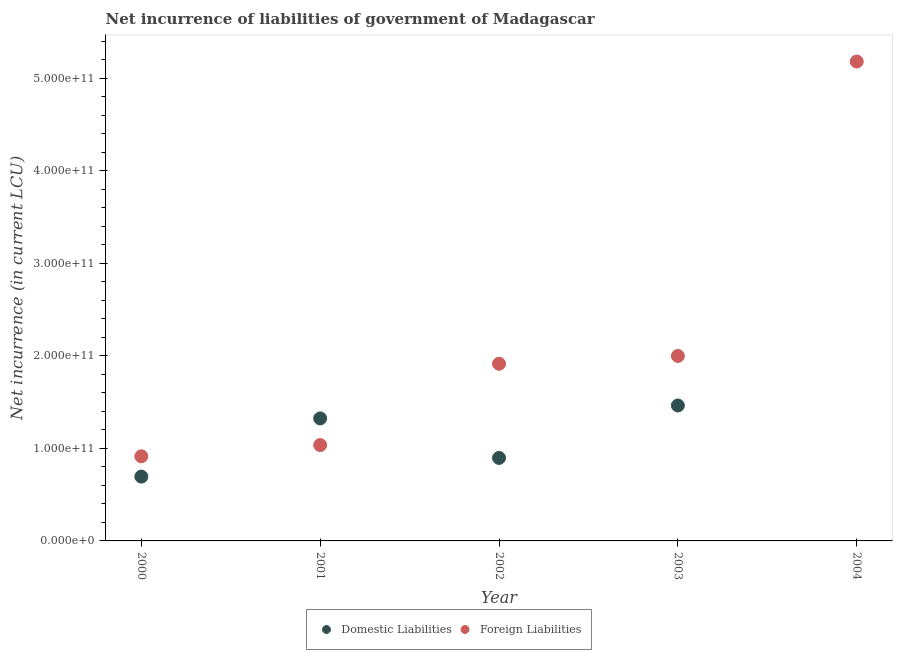Is the number of dotlines equal to the number of legend labels?
Offer a very short reply. No. What is the net incurrence of foreign liabilities in 2003?
Your answer should be compact. 2.00e+11. Across all years, what is the maximum net incurrence of domestic liabilities?
Provide a succinct answer. 1.46e+11. Across all years, what is the minimum net incurrence of domestic liabilities?
Keep it short and to the point. 0. What is the total net incurrence of domestic liabilities in the graph?
Provide a short and direct response. 4.38e+11. What is the difference between the net incurrence of foreign liabilities in 2001 and that in 2002?
Give a very brief answer. -8.79e+1. What is the difference between the net incurrence of domestic liabilities in 2000 and the net incurrence of foreign liabilities in 2004?
Provide a short and direct response. -4.49e+11. What is the average net incurrence of domestic liabilities per year?
Your answer should be very brief. 8.76e+1. In the year 2000, what is the difference between the net incurrence of domestic liabilities and net incurrence of foreign liabilities?
Keep it short and to the point. -2.20e+1. What is the ratio of the net incurrence of domestic liabilities in 2000 to that in 2002?
Ensure brevity in your answer.  0.77. Is the difference between the net incurrence of foreign liabilities in 2000 and 2001 greater than the difference between the net incurrence of domestic liabilities in 2000 and 2001?
Your response must be concise. Yes. What is the difference between the highest and the second highest net incurrence of domestic liabilities?
Offer a very short reply. 1.39e+1. What is the difference between the highest and the lowest net incurrence of domestic liabilities?
Your response must be concise. 1.46e+11. Is the net incurrence of domestic liabilities strictly less than the net incurrence of foreign liabilities over the years?
Offer a terse response. No. How many years are there in the graph?
Your answer should be compact. 5. What is the difference between two consecutive major ticks on the Y-axis?
Your response must be concise. 1.00e+11. What is the title of the graph?
Provide a short and direct response. Net incurrence of liabilities of government of Madagascar. Does "Diarrhea" appear as one of the legend labels in the graph?
Your answer should be compact. No. What is the label or title of the X-axis?
Provide a short and direct response. Year. What is the label or title of the Y-axis?
Provide a succinct answer. Net incurrence (in current LCU). What is the Net incurrence (in current LCU) of Domestic Liabilities in 2000?
Provide a short and direct response. 6.95e+1. What is the Net incurrence (in current LCU) of Foreign Liabilities in 2000?
Provide a short and direct response. 9.15e+1. What is the Net incurrence (in current LCU) in Domestic Liabilities in 2001?
Offer a terse response. 1.32e+11. What is the Net incurrence (in current LCU) in Foreign Liabilities in 2001?
Make the answer very short. 1.04e+11. What is the Net incurrence (in current LCU) of Domestic Liabilities in 2002?
Keep it short and to the point. 8.97e+1. What is the Net incurrence (in current LCU) of Foreign Liabilities in 2002?
Keep it short and to the point. 1.92e+11. What is the Net incurrence (in current LCU) of Domestic Liabilities in 2003?
Offer a terse response. 1.46e+11. What is the Net incurrence (in current LCU) in Foreign Liabilities in 2003?
Keep it short and to the point. 2.00e+11. What is the Net incurrence (in current LCU) of Domestic Liabilities in 2004?
Ensure brevity in your answer.  0. What is the Net incurrence (in current LCU) of Foreign Liabilities in 2004?
Your response must be concise. 5.18e+11. Across all years, what is the maximum Net incurrence (in current LCU) in Domestic Liabilities?
Your answer should be very brief. 1.46e+11. Across all years, what is the maximum Net incurrence (in current LCU) of Foreign Liabilities?
Provide a succinct answer. 5.18e+11. Across all years, what is the minimum Net incurrence (in current LCU) of Domestic Liabilities?
Make the answer very short. 0. Across all years, what is the minimum Net incurrence (in current LCU) in Foreign Liabilities?
Give a very brief answer. 9.15e+1. What is the total Net incurrence (in current LCU) of Domestic Liabilities in the graph?
Offer a terse response. 4.38e+11. What is the total Net incurrence (in current LCU) in Foreign Liabilities in the graph?
Your answer should be very brief. 1.10e+12. What is the difference between the Net incurrence (in current LCU) in Domestic Liabilities in 2000 and that in 2001?
Offer a terse response. -6.29e+1. What is the difference between the Net incurrence (in current LCU) of Foreign Liabilities in 2000 and that in 2001?
Provide a short and direct response. -1.21e+1. What is the difference between the Net incurrence (in current LCU) in Domestic Liabilities in 2000 and that in 2002?
Your answer should be compact. -2.02e+1. What is the difference between the Net incurrence (in current LCU) in Foreign Liabilities in 2000 and that in 2002?
Offer a terse response. -1.00e+11. What is the difference between the Net incurrence (in current LCU) of Domestic Liabilities in 2000 and that in 2003?
Provide a succinct answer. -7.69e+1. What is the difference between the Net incurrence (in current LCU) in Foreign Liabilities in 2000 and that in 2003?
Give a very brief answer. -1.08e+11. What is the difference between the Net incurrence (in current LCU) in Foreign Liabilities in 2000 and that in 2004?
Provide a short and direct response. -4.27e+11. What is the difference between the Net incurrence (in current LCU) of Domestic Liabilities in 2001 and that in 2002?
Ensure brevity in your answer.  4.27e+1. What is the difference between the Net incurrence (in current LCU) in Foreign Liabilities in 2001 and that in 2002?
Ensure brevity in your answer.  -8.79e+1. What is the difference between the Net incurrence (in current LCU) of Domestic Liabilities in 2001 and that in 2003?
Give a very brief answer. -1.39e+1. What is the difference between the Net incurrence (in current LCU) of Foreign Liabilities in 2001 and that in 2003?
Offer a terse response. -9.64e+1. What is the difference between the Net incurrence (in current LCU) in Foreign Liabilities in 2001 and that in 2004?
Offer a very short reply. -4.15e+11. What is the difference between the Net incurrence (in current LCU) of Domestic Liabilities in 2002 and that in 2003?
Your response must be concise. -5.67e+1. What is the difference between the Net incurrence (in current LCU) of Foreign Liabilities in 2002 and that in 2003?
Your response must be concise. -8.48e+09. What is the difference between the Net incurrence (in current LCU) in Foreign Liabilities in 2002 and that in 2004?
Keep it short and to the point. -3.27e+11. What is the difference between the Net incurrence (in current LCU) in Foreign Liabilities in 2003 and that in 2004?
Ensure brevity in your answer.  -3.18e+11. What is the difference between the Net incurrence (in current LCU) in Domestic Liabilities in 2000 and the Net incurrence (in current LCU) in Foreign Liabilities in 2001?
Your answer should be very brief. -3.41e+1. What is the difference between the Net incurrence (in current LCU) in Domestic Liabilities in 2000 and the Net incurrence (in current LCU) in Foreign Liabilities in 2002?
Your answer should be very brief. -1.22e+11. What is the difference between the Net incurrence (in current LCU) in Domestic Liabilities in 2000 and the Net incurrence (in current LCU) in Foreign Liabilities in 2003?
Offer a very short reply. -1.30e+11. What is the difference between the Net incurrence (in current LCU) in Domestic Liabilities in 2000 and the Net incurrence (in current LCU) in Foreign Liabilities in 2004?
Offer a terse response. -4.49e+11. What is the difference between the Net incurrence (in current LCU) in Domestic Liabilities in 2001 and the Net incurrence (in current LCU) in Foreign Liabilities in 2002?
Ensure brevity in your answer.  -5.91e+1. What is the difference between the Net incurrence (in current LCU) in Domestic Liabilities in 2001 and the Net incurrence (in current LCU) in Foreign Liabilities in 2003?
Provide a succinct answer. -6.75e+1. What is the difference between the Net incurrence (in current LCU) of Domestic Liabilities in 2001 and the Net incurrence (in current LCU) of Foreign Liabilities in 2004?
Offer a very short reply. -3.86e+11. What is the difference between the Net incurrence (in current LCU) of Domestic Liabilities in 2002 and the Net incurrence (in current LCU) of Foreign Liabilities in 2003?
Your response must be concise. -1.10e+11. What is the difference between the Net incurrence (in current LCU) of Domestic Liabilities in 2002 and the Net incurrence (in current LCU) of Foreign Liabilities in 2004?
Provide a succinct answer. -4.28e+11. What is the difference between the Net incurrence (in current LCU) of Domestic Liabilities in 2003 and the Net incurrence (in current LCU) of Foreign Liabilities in 2004?
Provide a succinct answer. -3.72e+11. What is the average Net incurrence (in current LCU) of Domestic Liabilities per year?
Make the answer very short. 8.76e+1. What is the average Net incurrence (in current LCU) of Foreign Liabilities per year?
Your answer should be very brief. 2.21e+11. In the year 2000, what is the difference between the Net incurrence (in current LCU) of Domestic Liabilities and Net incurrence (in current LCU) of Foreign Liabilities?
Offer a very short reply. -2.20e+1. In the year 2001, what is the difference between the Net incurrence (in current LCU) in Domestic Liabilities and Net incurrence (in current LCU) in Foreign Liabilities?
Give a very brief answer. 2.88e+1. In the year 2002, what is the difference between the Net incurrence (in current LCU) in Domestic Liabilities and Net incurrence (in current LCU) in Foreign Liabilities?
Your answer should be very brief. -1.02e+11. In the year 2003, what is the difference between the Net incurrence (in current LCU) in Domestic Liabilities and Net incurrence (in current LCU) in Foreign Liabilities?
Provide a succinct answer. -5.36e+1. What is the ratio of the Net incurrence (in current LCU) in Domestic Liabilities in 2000 to that in 2001?
Provide a succinct answer. 0.52. What is the ratio of the Net incurrence (in current LCU) of Foreign Liabilities in 2000 to that in 2001?
Give a very brief answer. 0.88. What is the ratio of the Net incurrence (in current LCU) of Domestic Liabilities in 2000 to that in 2002?
Offer a very short reply. 0.77. What is the ratio of the Net incurrence (in current LCU) of Foreign Liabilities in 2000 to that in 2002?
Make the answer very short. 0.48. What is the ratio of the Net incurrence (in current LCU) in Domestic Liabilities in 2000 to that in 2003?
Your answer should be very brief. 0.47. What is the ratio of the Net incurrence (in current LCU) of Foreign Liabilities in 2000 to that in 2003?
Make the answer very short. 0.46. What is the ratio of the Net incurrence (in current LCU) of Foreign Liabilities in 2000 to that in 2004?
Provide a short and direct response. 0.18. What is the ratio of the Net incurrence (in current LCU) in Domestic Liabilities in 2001 to that in 2002?
Keep it short and to the point. 1.48. What is the ratio of the Net incurrence (in current LCU) of Foreign Liabilities in 2001 to that in 2002?
Your answer should be very brief. 0.54. What is the ratio of the Net incurrence (in current LCU) in Domestic Liabilities in 2001 to that in 2003?
Your answer should be very brief. 0.9. What is the ratio of the Net incurrence (in current LCU) in Foreign Liabilities in 2001 to that in 2003?
Offer a terse response. 0.52. What is the ratio of the Net incurrence (in current LCU) in Foreign Liabilities in 2001 to that in 2004?
Give a very brief answer. 0.2. What is the ratio of the Net incurrence (in current LCU) in Domestic Liabilities in 2002 to that in 2003?
Keep it short and to the point. 0.61. What is the ratio of the Net incurrence (in current LCU) in Foreign Liabilities in 2002 to that in 2003?
Offer a very short reply. 0.96. What is the ratio of the Net incurrence (in current LCU) in Foreign Liabilities in 2002 to that in 2004?
Provide a short and direct response. 0.37. What is the ratio of the Net incurrence (in current LCU) in Foreign Liabilities in 2003 to that in 2004?
Make the answer very short. 0.39. What is the difference between the highest and the second highest Net incurrence (in current LCU) in Domestic Liabilities?
Keep it short and to the point. 1.39e+1. What is the difference between the highest and the second highest Net incurrence (in current LCU) in Foreign Liabilities?
Provide a succinct answer. 3.18e+11. What is the difference between the highest and the lowest Net incurrence (in current LCU) in Domestic Liabilities?
Your answer should be very brief. 1.46e+11. What is the difference between the highest and the lowest Net incurrence (in current LCU) in Foreign Liabilities?
Ensure brevity in your answer.  4.27e+11. 